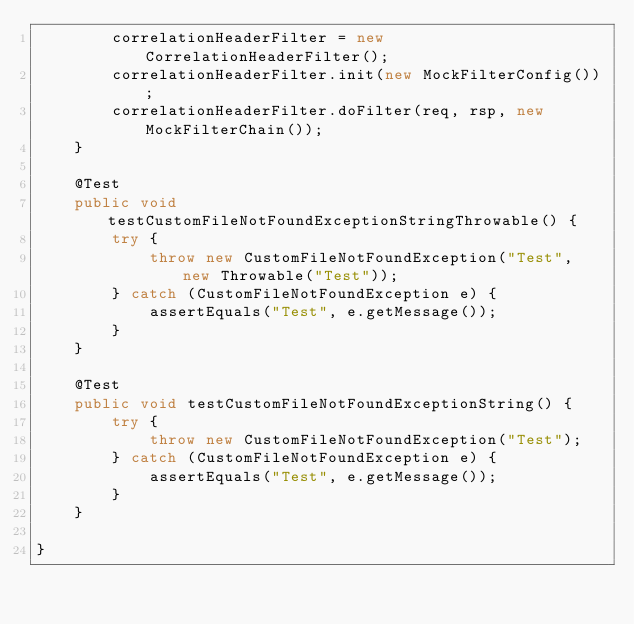Convert code to text. <code><loc_0><loc_0><loc_500><loc_500><_Java_>		correlationHeaderFilter = new CorrelationHeaderFilter();
		correlationHeaderFilter.init(new MockFilterConfig());
		correlationHeaderFilter.doFilter(req, rsp, new MockFilterChain());
	}

	@Test
	public void testCustomFileNotFoundExceptionStringThrowable() {
		try {
			throw new CustomFileNotFoundException("Test", new Throwable("Test"));
		} catch (CustomFileNotFoundException e) {
			assertEquals("Test", e.getMessage());
		}
	}

	@Test
	public void testCustomFileNotFoundExceptionString() {
		try {
			throw new CustomFileNotFoundException("Test");
		} catch (CustomFileNotFoundException e) {
			assertEquals("Test", e.getMessage());
		}
	}

}
</code> 